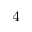Convert formula to latex. <formula><loc_0><loc_0><loc_500><loc_500>^ { 4 }</formula> 